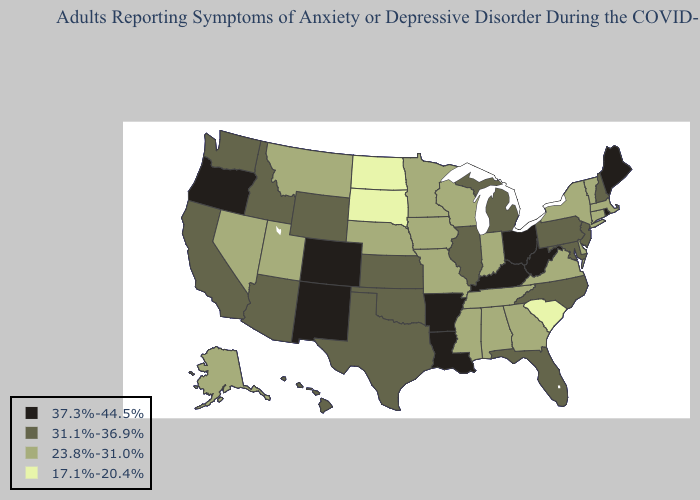What is the lowest value in the USA?
Answer briefly. 17.1%-20.4%. What is the lowest value in states that border Kansas?
Concise answer only. 23.8%-31.0%. Does Rhode Island have the highest value in the USA?
Keep it brief. Yes. Which states have the lowest value in the USA?
Quick response, please. North Dakota, South Carolina, South Dakota. Among the states that border Massachusetts , does Rhode Island have the lowest value?
Short answer required. No. Among the states that border New York , does Connecticut have the lowest value?
Write a very short answer. Yes. Among the states that border Iowa , does Illinois have the highest value?
Answer briefly. Yes. Among the states that border Pennsylvania , which have the lowest value?
Give a very brief answer. Delaware, New York. Name the states that have a value in the range 23.8%-31.0%?
Quick response, please. Alabama, Alaska, Connecticut, Delaware, Georgia, Indiana, Iowa, Massachusetts, Minnesota, Mississippi, Missouri, Montana, Nebraska, Nevada, New York, Tennessee, Utah, Vermont, Virginia, Wisconsin. Among the states that border Wyoming , which have the lowest value?
Keep it brief. South Dakota. What is the highest value in the USA?
Short answer required. 37.3%-44.5%. Is the legend a continuous bar?
Give a very brief answer. No. Does Washington have the lowest value in the West?
Answer briefly. No. What is the value of Maine?
Be succinct. 37.3%-44.5%. 